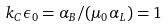<formula> <loc_0><loc_0><loc_500><loc_500>k _ { C } \epsilon _ { 0 } = \alpha _ { B } / ( \mu _ { 0 } \alpha _ { L } ) = 1</formula> 